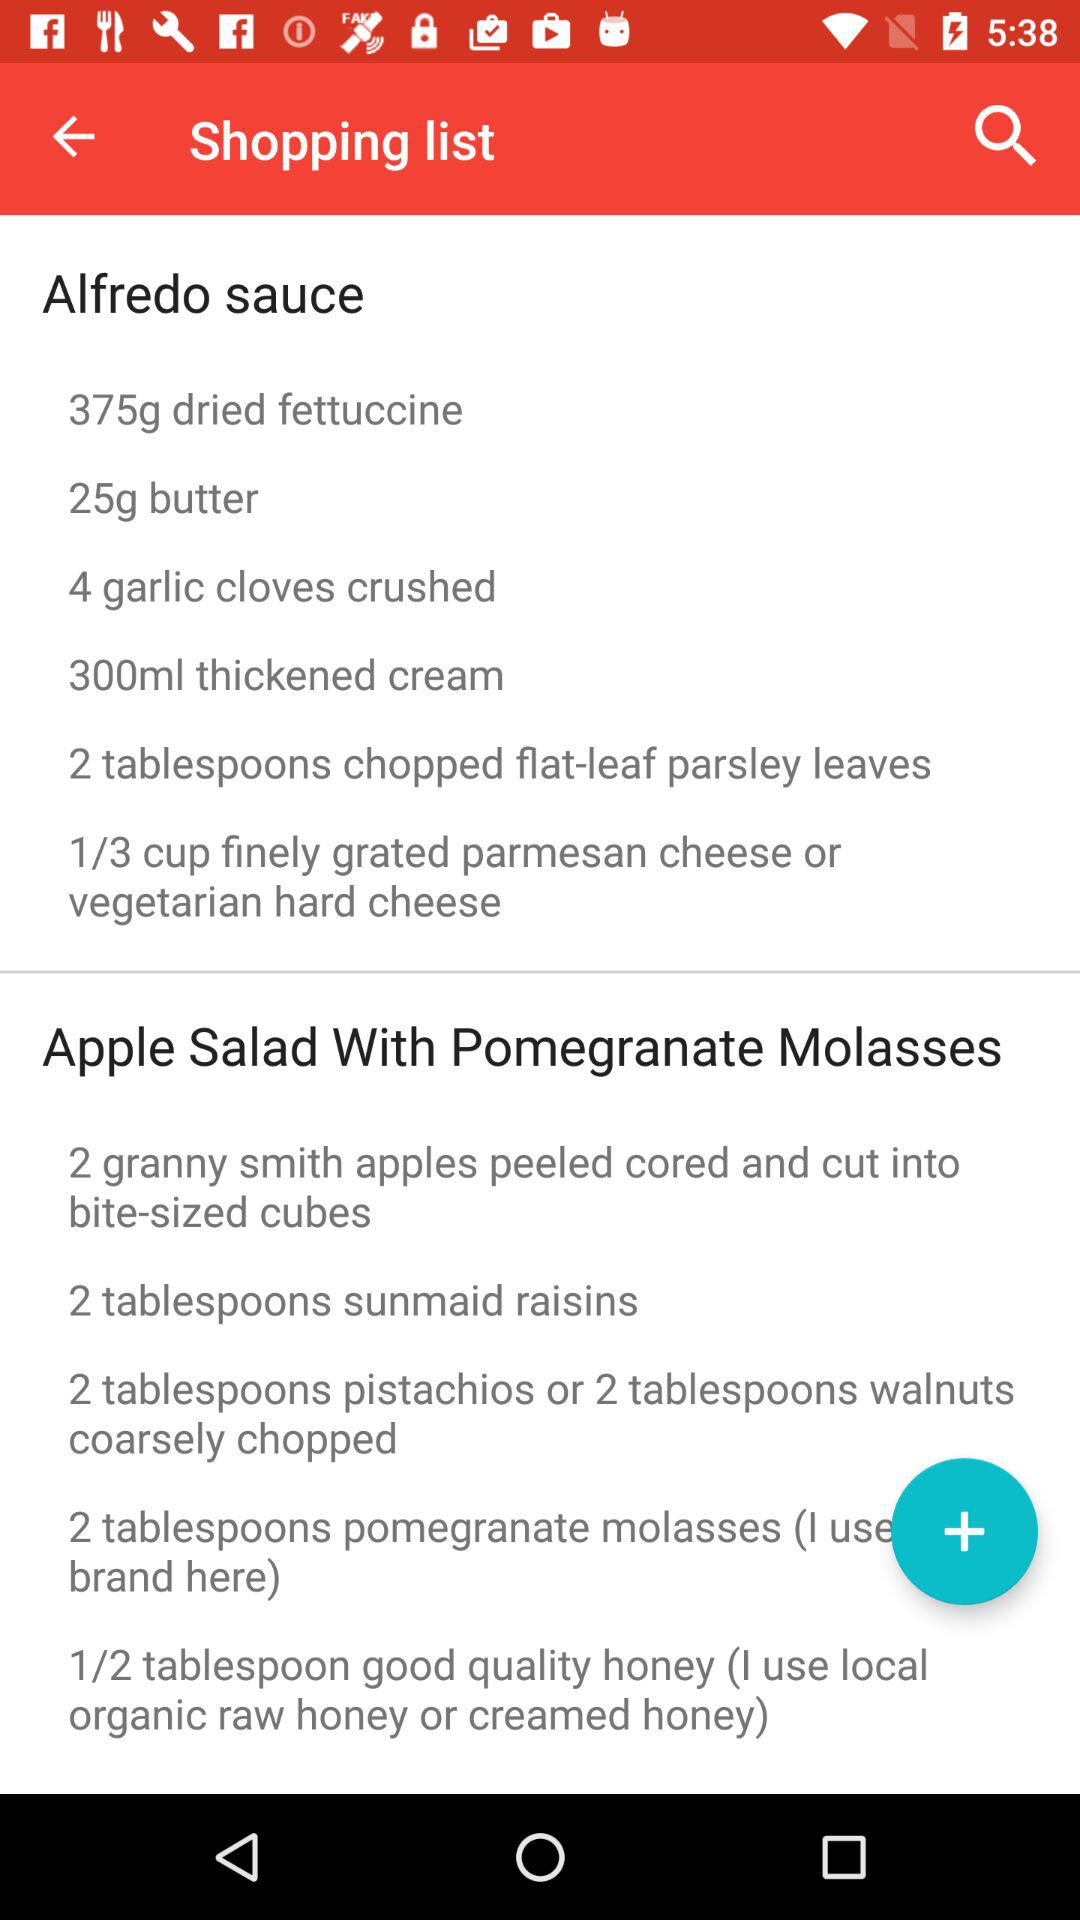How much butter is required in Alfredo sauce? The amount of butter required is 25g. 